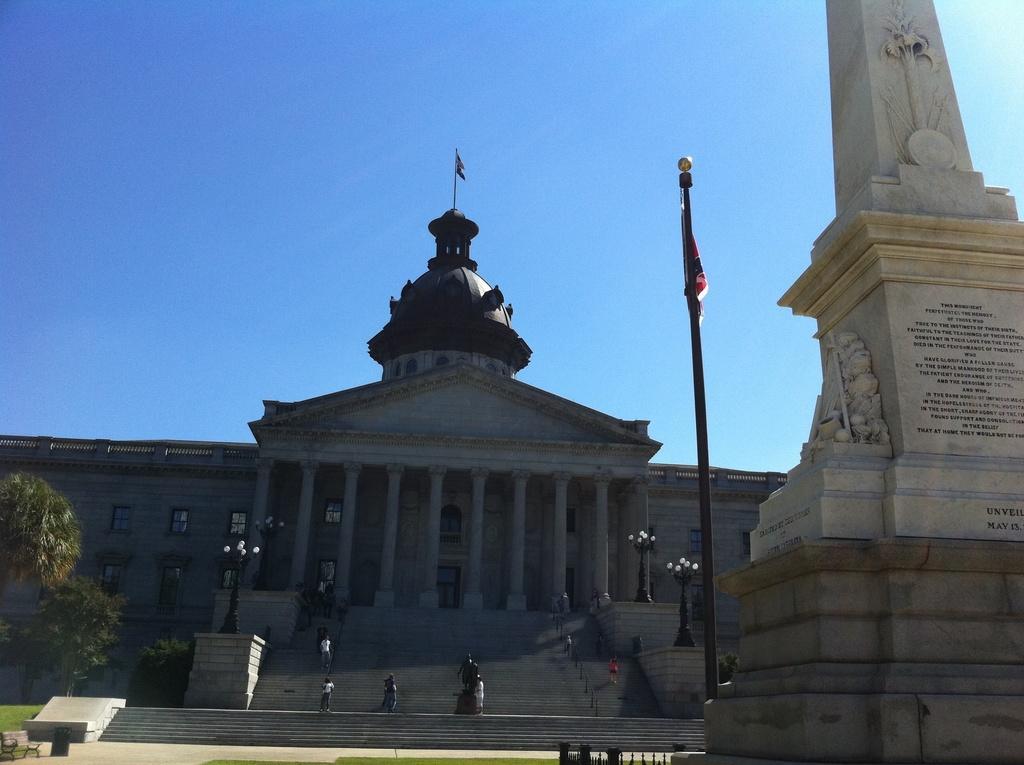Please provide a concise description of this image. On the right side, there is a pillar and a pole, which is having a flag. On the left side, there are trees. In the background, there are persons on the steps of a building, which is having a flag arranged on the top, windows, lights attached to the poles and there are clouds in the blue sky. 